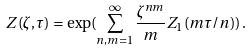Convert formula to latex. <formula><loc_0><loc_0><loc_500><loc_500>Z ( \zeta , \tau ) = \exp ( \sum _ { n , m = 1 } ^ { \infty } \frac { \zeta ^ { n m } } { m } Z _ { 1 } ( m \tau / n ) ) \, .</formula> 